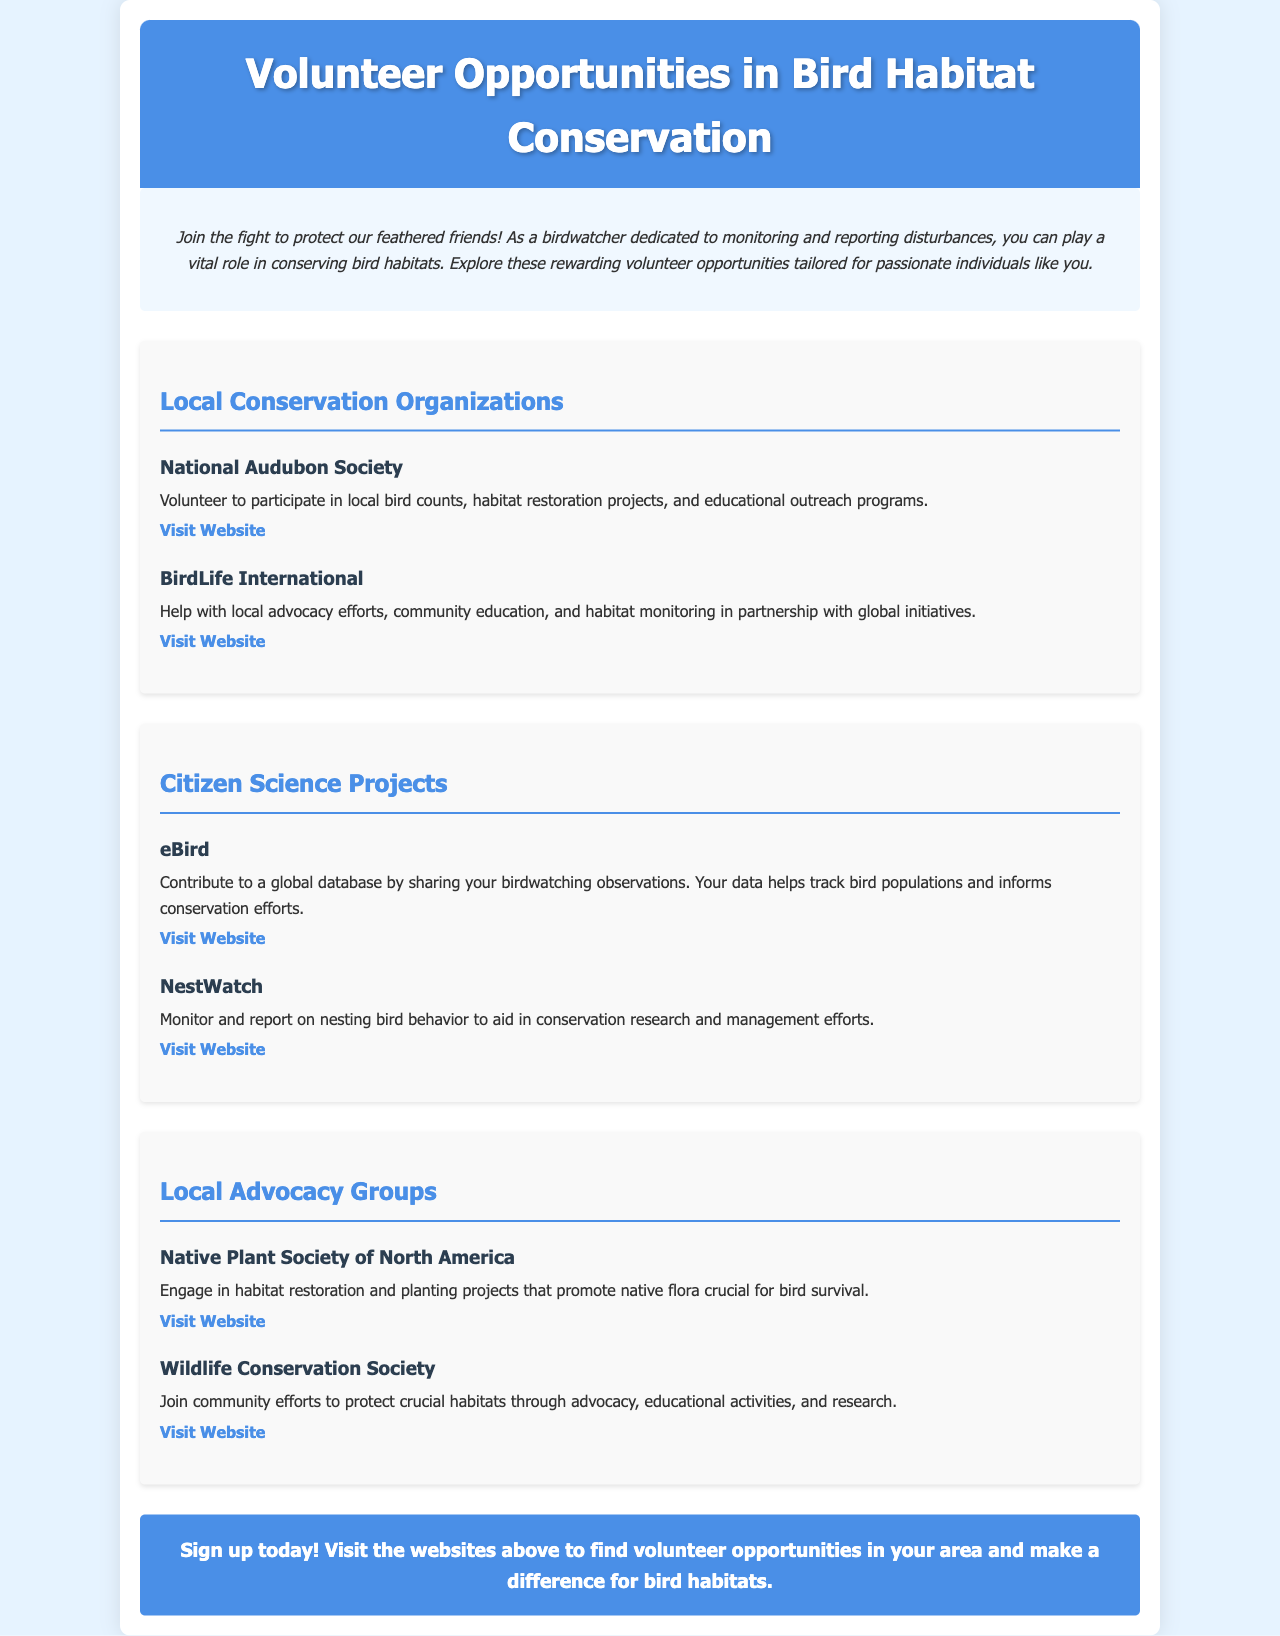what is the title of the brochure? The title is prominently displayed at the top of the document.
Answer: Volunteer Opportunities in Bird Habitat Conservation how many local conservation organizations are listed? The document specifies a section for local conservation organizations with two entries.
Answer: 2 which organization helps with local advocacy efforts? The information about local advocacy efforts can be found under the section for conservation organizations.
Answer: BirdLife International what can you monitor with NestWatch? The document describes the focus of the NestWatch program regarding bird behavior.
Answer: nesting bird behavior which website can you visit to contribute to a global database? The eBird section includes a direct link to its website for contributions.
Answer: eBird what initiative does the Native Plant Society of North America focus on? The document states the engagement of the Native Plant Society in specific activities.
Answer: habitat restoration which color is used for the header background? The header background color is specified in the document styles.
Answer: #4a8fe7 how is the introduction section styled? The introduction section has specific styling details mentioned in the document.
Answer: italic and centered what action does the CTA encourage? The call to action encourages readers to take specific steps regarding volunteering.
Answer: Sign up today! 